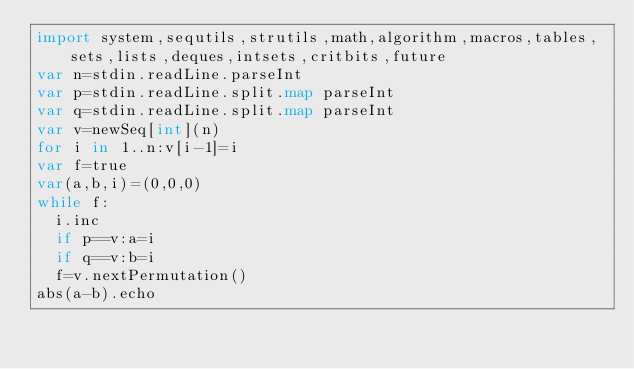Convert code to text. <code><loc_0><loc_0><loc_500><loc_500><_Nim_>import system,sequtils,strutils,math,algorithm,macros,tables,sets,lists,deques,intsets,critbits,future
var n=stdin.readLine.parseInt
var p=stdin.readLine.split.map parseInt
var q=stdin.readLine.split.map parseInt
var v=newSeq[int](n)
for i in 1..n:v[i-1]=i
var f=true
var(a,b,i)=(0,0,0)
while f:
  i.inc
  if p==v:a=i
  if q==v:b=i
  f=v.nextPermutation()
abs(a-b).echo</code> 